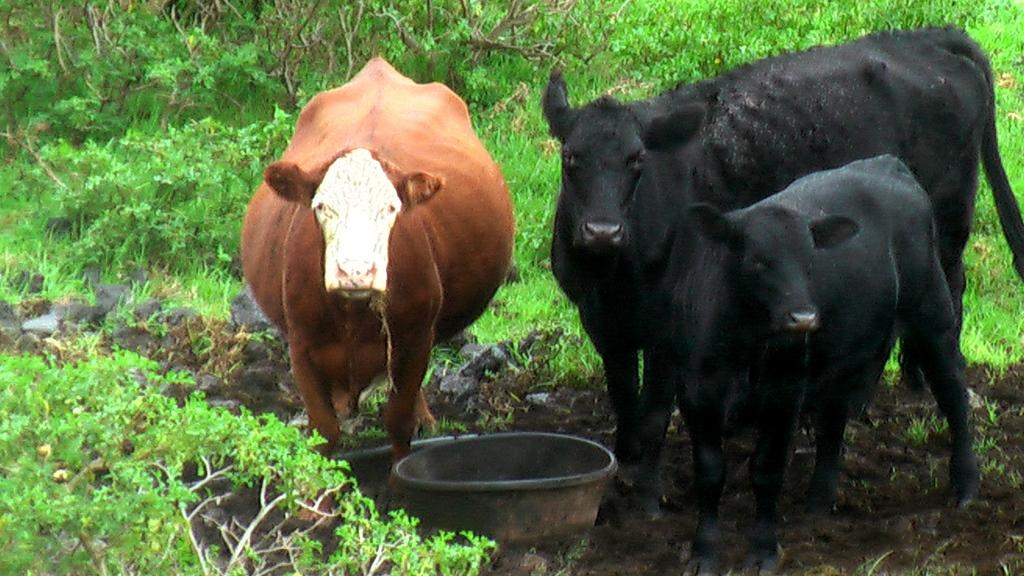How many cows are present in the image? There are three cows standing in the image. What object can be seen in the image besides the cows? There appears to be a tub in the image. What type of vegetation is visible in the image? There are plants visible in the image. What type of humor can be seen in the image? There is no humor present in the image; it features three cows and a tub. Can you tell me how many thumbs are visible in the image? There are no thumbs visible in the image. Is there a volleyball game taking place in the image? There is no volleyball game present in the image. 